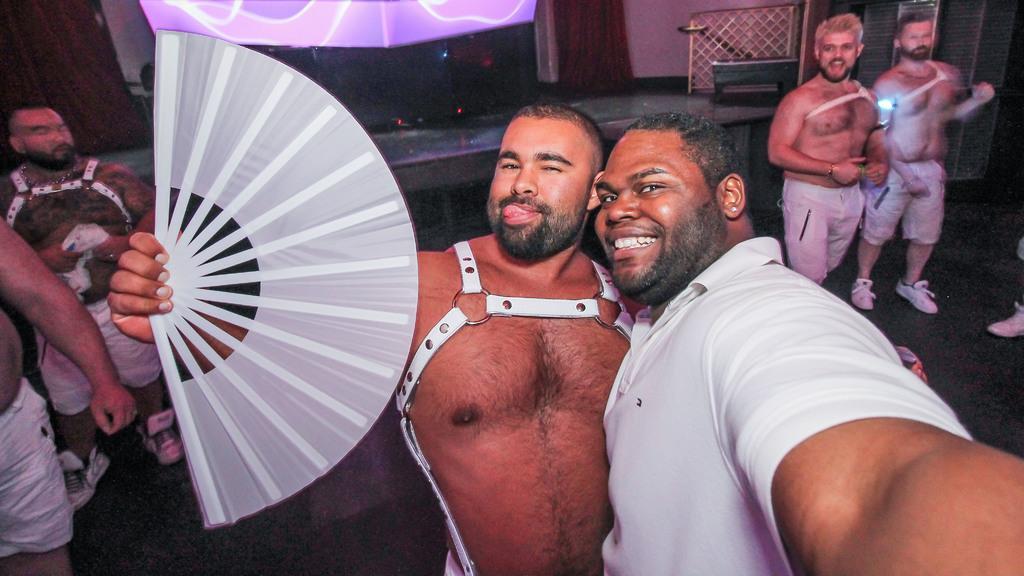Could you give a brief overview of what you see in this image? This picture is clicked inside. In the center there is a person holding a white color rigid fan and standing and we can see the group of persons standing on the ground. In the background we can see the wall and some other objects. 